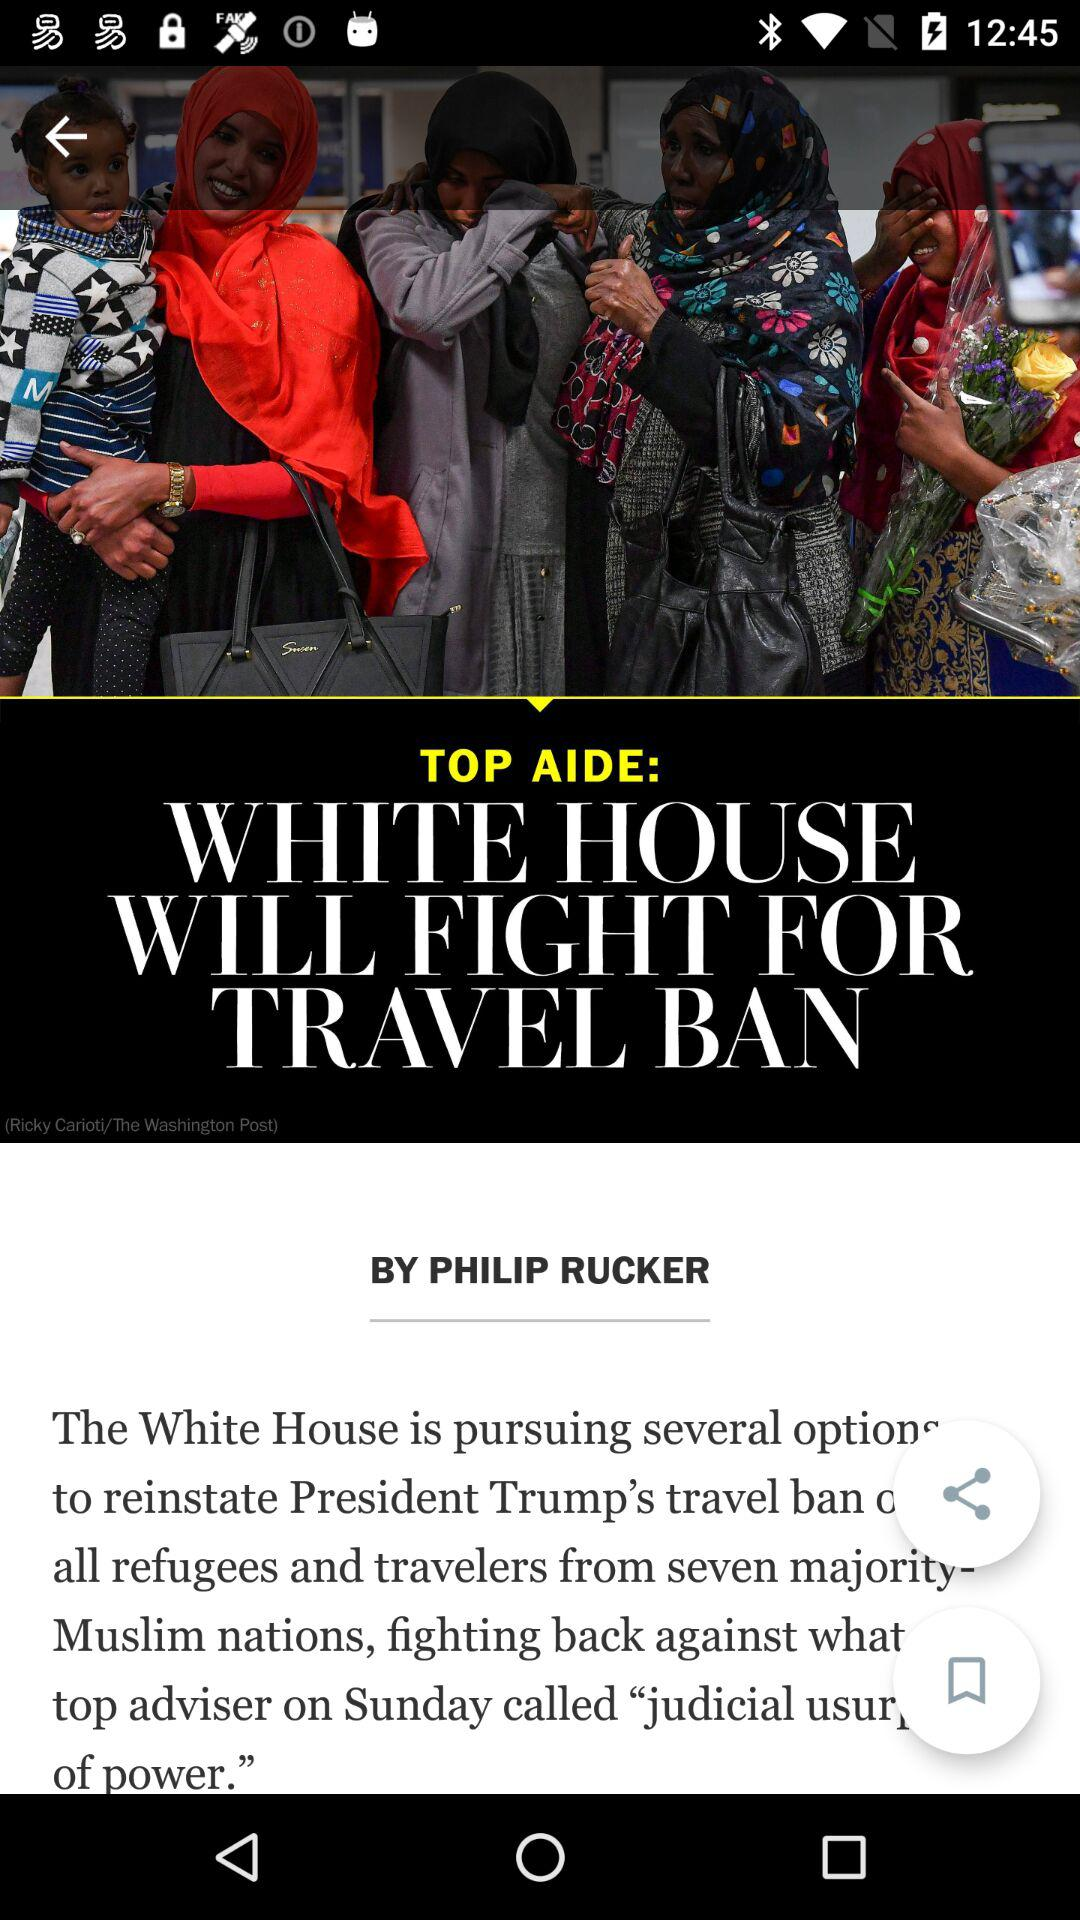What is the title? The title is "White House will fight for travel ban". 